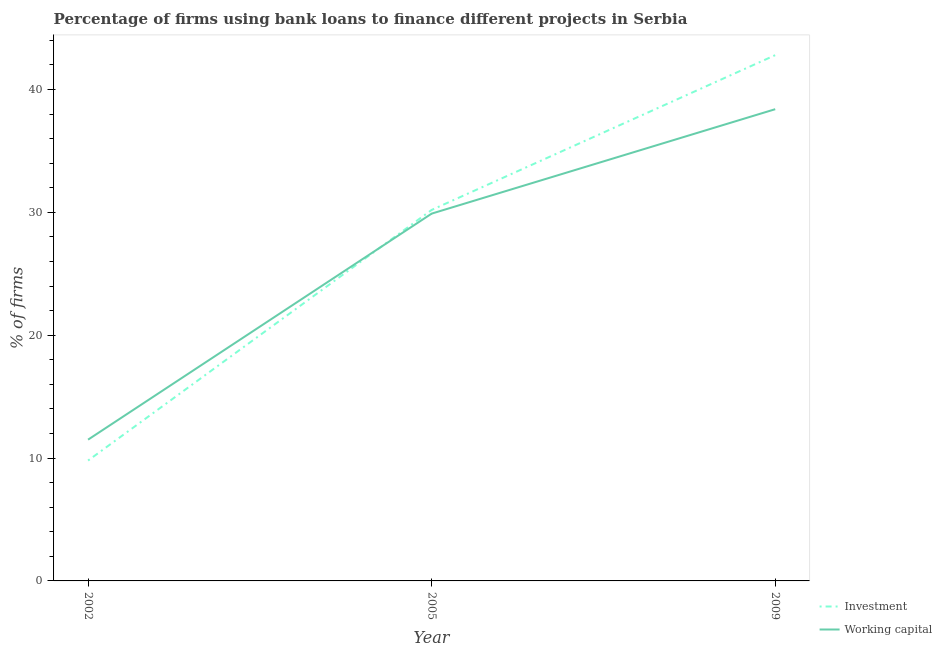Does the line corresponding to percentage of firms using banks to finance investment intersect with the line corresponding to percentage of firms using banks to finance working capital?
Your answer should be very brief. Yes. Is the number of lines equal to the number of legend labels?
Ensure brevity in your answer.  Yes. What is the percentage of firms using banks to finance working capital in 2009?
Offer a terse response. 38.4. Across all years, what is the maximum percentage of firms using banks to finance investment?
Your response must be concise. 42.8. Across all years, what is the minimum percentage of firms using banks to finance working capital?
Give a very brief answer. 11.5. What is the total percentage of firms using banks to finance investment in the graph?
Your answer should be very brief. 82.8. What is the difference between the percentage of firms using banks to finance investment in 2002 and that in 2009?
Ensure brevity in your answer.  -33. What is the difference between the percentage of firms using banks to finance working capital in 2005 and the percentage of firms using banks to finance investment in 2002?
Your answer should be very brief. 20.1. What is the average percentage of firms using banks to finance investment per year?
Provide a succinct answer. 27.6. In the year 2005, what is the difference between the percentage of firms using banks to finance working capital and percentage of firms using banks to finance investment?
Your answer should be compact. -0.3. In how many years, is the percentage of firms using banks to finance investment greater than 28 %?
Your response must be concise. 2. What is the ratio of the percentage of firms using banks to finance investment in 2002 to that in 2005?
Ensure brevity in your answer.  0.32. Is the difference between the percentage of firms using banks to finance working capital in 2002 and 2005 greater than the difference between the percentage of firms using banks to finance investment in 2002 and 2005?
Your answer should be compact. Yes. What is the difference between the highest and the lowest percentage of firms using banks to finance working capital?
Keep it short and to the point. 26.9. In how many years, is the percentage of firms using banks to finance investment greater than the average percentage of firms using banks to finance investment taken over all years?
Make the answer very short. 2. How many lines are there?
Your answer should be very brief. 2. Are the values on the major ticks of Y-axis written in scientific E-notation?
Offer a terse response. No. How are the legend labels stacked?
Offer a very short reply. Vertical. What is the title of the graph?
Offer a very short reply. Percentage of firms using bank loans to finance different projects in Serbia. What is the label or title of the X-axis?
Offer a terse response. Year. What is the label or title of the Y-axis?
Offer a very short reply. % of firms. What is the % of firms of Investment in 2002?
Provide a short and direct response. 9.8. What is the % of firms of Investment in 2005?
Ensure brevity in your answer.  30.2. What is the % of firms of Working capital in 2005?
Keep it short and to the point. 29.9. What is the % of firms of Investment in 2009?
Offer a terse response. 42.8. What is the % of firms in Working capital in 2009?
Give a very brief answer. 38.4. Across all years, what is the maximum % of firms of Investment?
Offer a very short reply. 42.8. Across all years, what is the maximum % of firms of Working capital?
Provide a short and direct response. 38.4. What is the total % of firms in Investment in the graph?
Provide a succinct answer. 82.8. What is the total % of firms of Working capital in the graph?
Provide a short and direct response. 79.8. What is the difference between the % of firms in Investment in 2002 and that in 2005?
Your answer should be very brief. -20.4. What is the difference between the % of firms of Working capital in 2002 and that in 2005?
Your response must be concise. -18.4. What is the difference between the % of firms of Investment in 2002 and that in 2009?
Give a very brief answer. -33. What is the difference between the % of firms in Working capital in 2002 and that in 2009?
Give a very brief answer. -26.9. What is the difference between the % of firms in Investment in 2005 and that in 2009?
Provide a short and direct response. -12.6. What is the difference between the % of firms of Investment in 2002 and the % of firms of Working capital in 2005?
Offer a very short reply. -20.1. What is the difference between the % of firms in Investment in 2002 and the % of firms in Working capital in 2009?
Offer a terse response. -28.6. What is the difference between the % of firms in Investment in 2005 and the % of firms in Working capital in 2009?
Your answer should be compact. -8.2. What is the average % of firms in Investment per year?
Provide a succinct answer. 27.6. What is the average % of firms in Working capital per year?
Give a very brief answer. 26.6. In the year 2002, what is the difference between the % of firms of Investment and % of firms of Working capital?
Provide a short and direct response. -1.7. What is the ratio of the % of firms of Investment in 2002 to that in 2005?
Ensure brevity in your answer.  0.32. What is the ratio of the % of firms in Working capital in 2002 to that in 2005?
Ensure brevity in your answer.  0.38. What is the ratio of the % of firms in Investment in 2002 to that in 2009?
Your answer should be compact. 0.23. What is the ratio of the % of firms in Working capital in 2002 to that in 2009?
Offer a very short reply. 0.3. What is the ratio of the % of firms in Investment in 2005 to that in 2009?
Ensure brevity in your answer.  0.71. What is the ratio of the % of firms in Working capital in 2005 to that in 2009?
Provide a succinct answer. 0.78. What is the difference between the highest and the second highest % of firms in Investment?
Ensure brevity in your answer.  12.6. What is the difference between the highest and the lowest % of firms of Investment?
Make the answer very short. 33. What is the difference between the highest and the lowest % of firms in Working capital?
Make the answer very short. 26.9. 